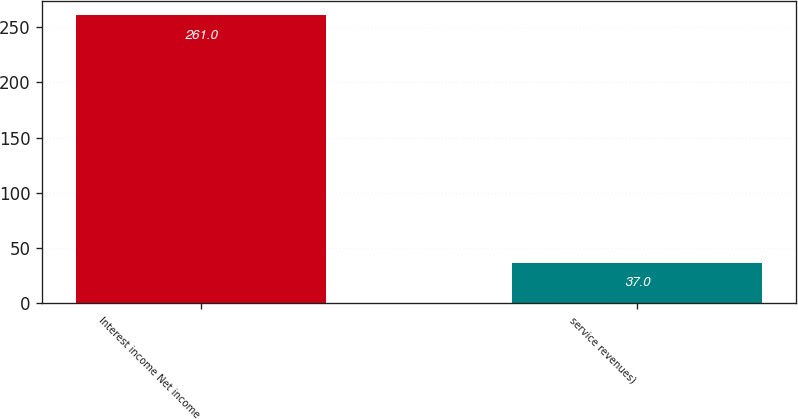<chart> <loc_0><loc_0><loc_500><loc_500><bar_chart><fcel>Interest income Net income<fcel>service revenues)<nl><fcel>261<fcel>37<nl></chart> 